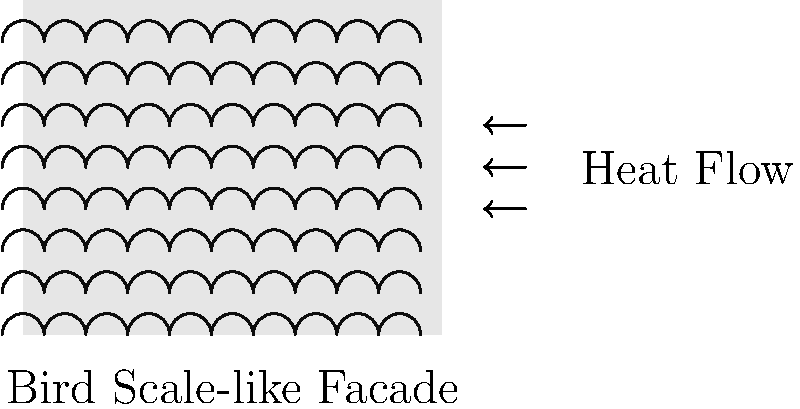In your latest fashion-inspired building design, you've incorporated a bird scale-like texture on the facade. How does this texture potentially affect the thermal insulation properties of the building compared to a smooth facade, and what principle of heat transfer is most relevant to this effect? To understand the thermal insulation properties of the bird scale-like facade, we need to consider the following steps:

1. Surface area: The bird scale-like texture increases the surface area of the facade compared to a smooth surface. This is similar to how bird feathers create air pockets for insulation.

2. Air pockets: The texture creates small air pockets between the scales, which act as additional insulation layers.

3. Boundary layer: The textured surface affects the boundary layer of air next to the facade, potentially reducing convective heat transfer.

4. Radiation: The scales may also influence the radiative heat transfer properties of the facade by changing its emissivity and absorption characteristics.

5. Principle of heat transfer: The most relevant principle here is convective heat transfer. The scales disrupt the smooth flow of air along the facade, creating a thicker boundary layer and reducing the convective heat transfer coefficient.

6. Thermal resistance: The overall effect is an increase in the thermal resistance (R-value) of the facade system, which can be expressed as:

   $$R_{total} = R_{smooth} + R_{texture}$$

   Where $R_{texture}$ represents the additional thermal resistance provided by the scale-like texture.

7. Heat flux: The reduced heat flux through the facade can be described by Fourier's law of heat conduction:

   $$q = -k \frac{dT}{dx}$$

   Where $q$ is the heat flux, $k$ is the thermal conductivity, and $\frac{dT}{dx}$ is the temperature gradient.

The bird scale-like texture effectively reduces the heat flux by increasing the overall thermal resistance of the facade system, primarily through its effect on convective heat transfer.
Answer: Increased thermal insulation due to enhanced convective heat transfer resistance 